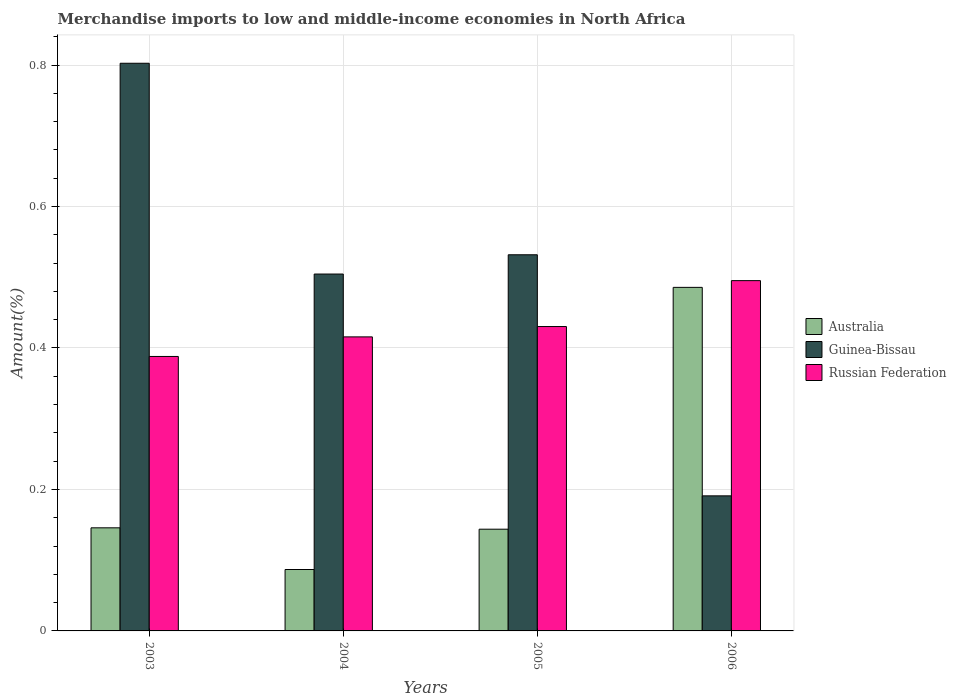How many different coloured bars are there?
Your response must be concise. 3. How many groups of bars are there?
Ensure brevity in your answer.  4. Are the number of bars per tick equal to the number of legend labels?
Ensure brevity in your answer.  Yes. How many bars are there on the 2nd tick from the left?
Offer a terse response. 3. In how many cases, is the number of bars for a given year not equal to the number of legend labels?
Your answer should be compact. 0. What is the percentage of amount earned from merchandise imports in Australia in 2006?
Make the answer very short. 0.49. Across all years, what is the maximum percentage of amount earned from merchandise imports in Australia?
Your answer should be very brief. 0.49. Across all years, what is the minimum percentage of amount earned from merchandise imports in Guinea-Bissau?
Your answer should be compact. 0.19. What is the total percentage of amount earned from merchandise imports in Australia in the graph?
Ensure brevity in your answer.  0.86. What is the difference between the percentage of amount earned from merchandise imports in Australia in 2005 and that in 2006?
Make the answer very short. -0.34. What is the difference between the percentage of amount earned from merchandise imports in Australia in 2003 and the percentage of amount earned from merchandise imports in Guinea-Bissau in 2006?
Provide a short and direct response. -0.05. What is the average percentage of amount earned from merchandise imports in Australia per year?
Provide a succinct answer. 0.22. In the year 2004, what is the difference between the percentage of amount earned from merchandise imports in Guinea-Bissau and percentage of amount earned from merchandise imports in Australia?
Keep it short and to the point. 0.42. What is the ratio of the percentage of amount earned from merchandise imports in Russian Federation in 2005 to that in 2006?
Your answer should be very brief. 0.87. Is the percentage of amount earned from merchandise imports in Russian Federation in 2003 less than that in 2005?
Ensure brevity in your answer.  Yes. Is the difference between the percentage of amount earned from merchandise imports in Guinea-Bissau in 2004 and 2006 greater than the difference between the percentage of amount earned from merchandise imports in Australia in 2004 and 2006?
Your answer should be very brief. Yes. What is the difference between the highest and the second highest percentage of amount earned from merchandise imports in Australia?
Your answer should be compact. 0.34. What is the difference between the highest and the lowest percentage of amount earned from merchandise imports in Russian Federation?
Your answer should be very brief. 0.11. Is the sum of the percentage of amount earned from merchandise imports in Australia in 2003 and 2006 greater than the maximum percentage of amount earned from merchandise imports in Guinea-Bissau across all years?
Offer a very short reply. No. What does the 2nd bar from the left in 2004 represents?
Offer a terse response. Guinea-Bissau. Are all the bars in the graph horizontal?
Your response must be concise. No. What is the difference between two consecutive major ticks on the Y-axis?
Make the answer very short. 0.2. Does the graph contain any zero values?
Offer a very short reply. No. Does the graph contain grids?
Provide a short and direct response. Yes. Where does the legend appear in the graph?
Provide a short and direct response. Center right. What is the title of the graph?
Provide a short and direct response. Merchandise imports to low and middle-income economies in North Africa. Does "OECD members" appear as one of the legend labels in the graph?
Provide a succinct answer. No. What is the label or title of the Y-axis?
Provide a short and direct response. Amount(%). What is the Amount(%) in Australia in 2003?
Provide a short and direct response. 0.15. What is the Amount(%) in Guinea-Bissau in 2003?
Keep it short and to the point. 0.8. What is the Amount(%) in Russian Federation in 2003?
Ensure brevity in your answer.  0.39. What is the Amount(%) of Australia in 2004?
Make the answer very short. 0.09. What is the Amount(%) in Guinea-Bissau in 2004?
Keep it short and to the point. 0.5. What is the Amount(%) in Russian Federation in 2004?
Make the answer very short. 0.42. What is the Amount(%) in Australia in 2005?
Give a very brief answer. 0.14. What is the Amount(%) of Guinea-Bissau in 2005?
Offer a terse response. 0.53. What is the Amount(%) in Russian Federation in 2005?
Your response must be concise. 0.43. What is the Amount(%) of Australia in 2006?
Your response must be concise. 0.49. What is the Amount(%) of Guinea-Bissau in 2006?
Your response must be concise. 0.19. What is the Amount(%) of Russian Federation in 2006?
Provide a short and direct response. 0.5. Across all years, what is the maximum Amount(%) in Australia?
Ensure brevity in your answer.  0.49. Across all years, what is the maximum Amount(%) in Guinea-Bissau?
Ensure brevity in your answer.  0.8. Across all years, what is the maximum Amount(%) in Russian Federation?
Your response must be concise. 0.5. Across all years, what is the minimum Amount(%) of Australia?
Your answer should be compact. 0.09. Across all years, what is the minimum Amount(%) in Guinea-Bissau?
Provide a short and direct response. 0.19. Across all years, what is the minimum Amount(%) of Russian Federation?
Your answer should be compact. 0.39. What is the total Amount(%) of Australia in the graph?
Make the answer very short. 0.86. What is the total Amount(%) of Guinea-Bissau in the graph?
Your answer should be compact. 2.03. What is the total Amount(%) of Russian Federation in the graph?
Provide a succinct answer. 1.73. What is the difference between the Amount(%) of Australia in 2003 and that in 2004?
Offer a terse response. 0.06. What is the difference between the Amount(%) in Guinea-Bissau in 2003 and that in 2004?
Your answer should be compact. 0.3. What is the difference between the Amount(%) of Russian Federation in 2003 and that in 2004?
Offer a terse response. -0.03. What is the difference between the Amount(%) in Australia in 2003 and that in 2005?
Ensure brevity in your answer.  0. What is the difference between the Amount(%) of Guinea-Bissau in 2003 and that in 2005?
Your answer should be very brief. 0.27. What is the difference between the Amount(%) in Russian Federation in 2003 and that in 2005?
Provide a short and direct response. -0.04. What is the difference between the Amount(%) of Australia in 2003 and that in 2006?
Your response must be concise. -0.34. What is the difference between the Amount(%) in Guinea-Bissau in 2003 and that in 2006?
Provide a short and direct response. 0.61. What is the difference between the Amount(%) of Russian Federation in 2003 and that in 2006?
Give a very brief answer. -0.11. What is the difference between the Amount(%) of Australia in 2004 and that in 2005?
Ensure brevity in your answer.  -0.06. What is the difference between the Amount(%) of Guinea-Bissau in 2004 and that in 2005?
Provide a succinct answer. -0.03. What is the difference between the Amount(%) of Russian Federation in 2004 and that in 2005?
Make the answer very short. -0.01. What is the difference between the Amount(%) in Australia in 2004 and that in 2006?
Give a very brief answer. -0.4. What is the difference between the Amount(%) in Guinea-Bissau in 2004 and that in 2006?
Your answer should be compact. 0.31. What is the difference between the Amount(%) of Russian Federation in 2004 and that in 2006?
Your answer should be very brief. -0.08. What is the difference between the Amount(%) in Australia in 2005 and that in 2006?
Give a very brief answer. -0.34. What is the difference between the Amount(%) of Guinea-Bissau in 2005 and that in 2006?
Provide a succinct answer. 0.34. What is the difference between the Amount(%) of Russian Federation in 2005 and that in 2006?
Provide a succinct answer. -0.06. What is the difference between the Amount(%) of Australia in 2003 and the Amount(%) of Guinea-Bissau in 2004?
Offer a terse response. -0.36. What is the difference between the Amount(%) of Australia in 2003 and the Amount(%) of Russian Federation in 2004?
Your response must be concise. -0.27. What is the difference between the Amount(%) of Guinea-Bissau in 2003 and the Amount(%) of Russian Federation in 2004?
Provide a succinct answer. 0.39. What is the difference between the Amount(%) in Australia in 2003 and the Amount(%) in Guinea-Bissau in 2005?
Provide a short and direct response. -0.39. What is the difference between the Amount(%) in Australia in 2003 and the Amount(%) in Russian Federation in 2005?
Offer a terse response. -0.28. What is the difference between the Amount(%) in Guinea-Bissau in 2003 and the Amount(%) in Russian Federation in 2005?
Make the answer very short. 0.37. What is the difference between the Amount(%) of Australia in 2003 and the Amount(%) of Guinea-Bissau in 2006?
Provide a short and direct response. -0.05. What is the difference between the Amount(%) of Australia in 2003 and the Amount(%) of Russian Federation in 2006?
Provide a short and direct response. -0.35. What is the difference between the Amount(%) of Guinea-Bissau in 2003 and the Amount(%) of Russian Federation in 2006?
Give a very brief answer. 0.31. What is the difference between the Amount(%) of Australia in 2004 and the Amount(%) of Guinea-Bissau in 2005?
Offer a very short reply. -0.44. What is the difference between the Amount(%) in Australia in 2004 and the Amount(%) in Russian Federation in 2005?
Provide a short and direct response. -0.34. What is the difference between the Amount(%) in Guinea-Bissau in 2004 and the Amount(%) in Russian Federation in 2005?
Ensure brevity in your answer.  0.07. What is the difference between the Amount(%) of Australia in 2004 and the Amount(%) of Guinea-Bissau in 2006?
Provide a short and direct response. -0.1. What is the difference between the Amount(%) in Australia in 2004 and the Amount(%) in Russian Federation in 2006?
Your answer should be very brief. -0.41. What is the difference between the Amount(%) of Guinea-Bissau in 2004 and the Amount(%) of Russian Federation in 2006?
Provide a short and direct response. 0.01. What is the difference between the Amount(%) of Australia in 2005 and the Amount(%) of Guinea-Bissau in 2006?
Keep it short and to the point. -0.05. What is the difference between the Amount(%) in Australia in 2005 and the Amount(%) in Russian Federation in 2006?
Ensure brevity in your answer.  -0.35. What is the difference between the Amount(%) in Guinea-Bissau in 2005 and the Amount(%) in Russian Federation in 2006?
Provide a succinct answer. 0.04. What is the average Amount(%) of Australia per year?
Make the answer very short. 0.22. What is the average Amount(%) in Guinea-Bissau per year?
Offer a terse response. 0.51. What is the average Amount(%) of Russian Federation per year?
Offer a very short reply. 0.43. In the year 2003, what is the difference between the Amount(%) in Australia and Amount(%) in Guinea-Bissau?
Your answer should be compact. -0.66. In the year 2003, what is the difference between the Amount(%) in Australia and Amount(%) in Russian Federation?
Ensure brevity in your answer.  -0.24. In the year 2003, what is the difference between the Amount(%) of Guinea-Bissau and Amount(%) of Russian Federation?
Give a very brief answer. 0.41. In the year 2004, what is the difference between the Amount(%) of Australia and Amount(%) of Guinea-Bissau?
Your answer should be compact. -0.42. In the year 2004, what is the difference between the Amount(%) in Australia and Amount(%) in Russian Federation?
Make the answer very short. -0.33. In the year 2004, what is the difference between the Amount(%) in Guinea-Bissau and Amount(%) in Russian Federation?
Your answer should be compact. 0.09. In the year 2005, what is the difference between the Amount(%) in Australia and Amount(%) in Guinea-Bissau?
Your response must be concise. -0.39. In the year 2005, what is the difference between the Amount(%) in Australia and Amount(%) in Russian Federation?
Your response must be concise. -0.29. In the year 2005, what is the difference between the Amount(%) in Guinea-Bissau and Amount(%) in Russian Federation?
Provide a short and direct response. 0.1. In the year 2006, what is the difference between the Amount(%) in Australia and Amount(%) in Guinea-Bissau?
Provide a short and direct response. 0.29. In the year 2006, what is the difference between the Amount(%) in Australia and Amount(%) in Russian Federation?
Your answer should be compact. -0.01. In the year 2006, what is the difference between the Amount(%) in Guinea-Bissau and Amount(%) in Russian Federation?
Your answer should be very brief. -0.3. What is the ratio of the Amount(%) in Australia in 2003 to that in 2004?
Make the answer very short. 1.68. What is the ratio of the Amount(%) of Guinea-Bissau in 2003 to that in 2004?
Make the answer very short. 1.59. What is the ratio of the Amount(%) of Russian Federation in 2003 to that in 2004?
Keep it short and to the point. 0.93. What is the ratio of the Amount(%) in Australia in 2003 to that in 2005?
Provide a short and direct response. 1.01. What is the ratio of the Amount(%) in Guinea-Bissau in 2003 to that in 2005?
Provide a succinct answer. 1.51. What is the ratio of the Amount(%) in Russian Federation in 2003 to that in 2005?
Offer a very short reply. 0.9. What is the ratio of the Amount(%) in Australia in 2003 to that in 2006?
Give a very brief answer. 0.3. What is the ratio of the Amount(%) in Guinea-Bissau in 2003 to that in 2006?
Your answer should be compact. 4.2. What is the ratio of the Amount(%) of Russian Federation in 2003 to that in 2006?
Your response must be concise. 0.78. What is the ratio of the Amount(%) of Australia in 2004 to that in 2005?
Your response must be concise. 0.6. What is the ratio of the Amount(%) in Guinea-Bissau in 2004 to that in 2005?
Offer a very short reply. 0.95. What is the ratio of the Amount(%) of Australia in 2004 to that in 2006?
Offer a very short reply. 0.18. What is the ratio of the Amount(%) of Guinea-Bissau in 2004 to that in 2006?
Give a very brief answer. 2.64. What is the ratio of the Amount(%) in Russian Federation in 2004 to that in 2006?
Make the answer very short. 0.84. What is the ratio of the Amount(%) of Australia in 2005 to that in 2006?
Ensure brevity in your answer.  0.3. What is the ratio of the Amount(%) in Guinea-Bissau in 2005 to that in 2006?
Ensure brevity in your answer.  2.78. What is the ratio of the Amount(%) in Russian Federation in 2005 to that in 2006?
Your response must be concise. 0.87. What is the difference between the highest and the second highest Amount(%) in Australia?
Ensure brevity in your answer.  0.34. What is the difference between the highest and the second highest Amount(%) of Guinea-Bissau?
Your response must be concise. 0.27. What is the difference between the highest and the second highest Amount(%) of Russian Federation?
Offer a very short reply. 0.06. What is the difference between the highest and the lowest Amount(%) in Australia?
Keep it short and to the point. 0.4. What is the difference between the highest and the lowest Amount(%) in Guinea-Bissau?
Keep it short and to the point. 0.61. What is the difference between the highest and the lowest Amount(%) in Russian Federation?
Offer a very short reply. 0.11. 